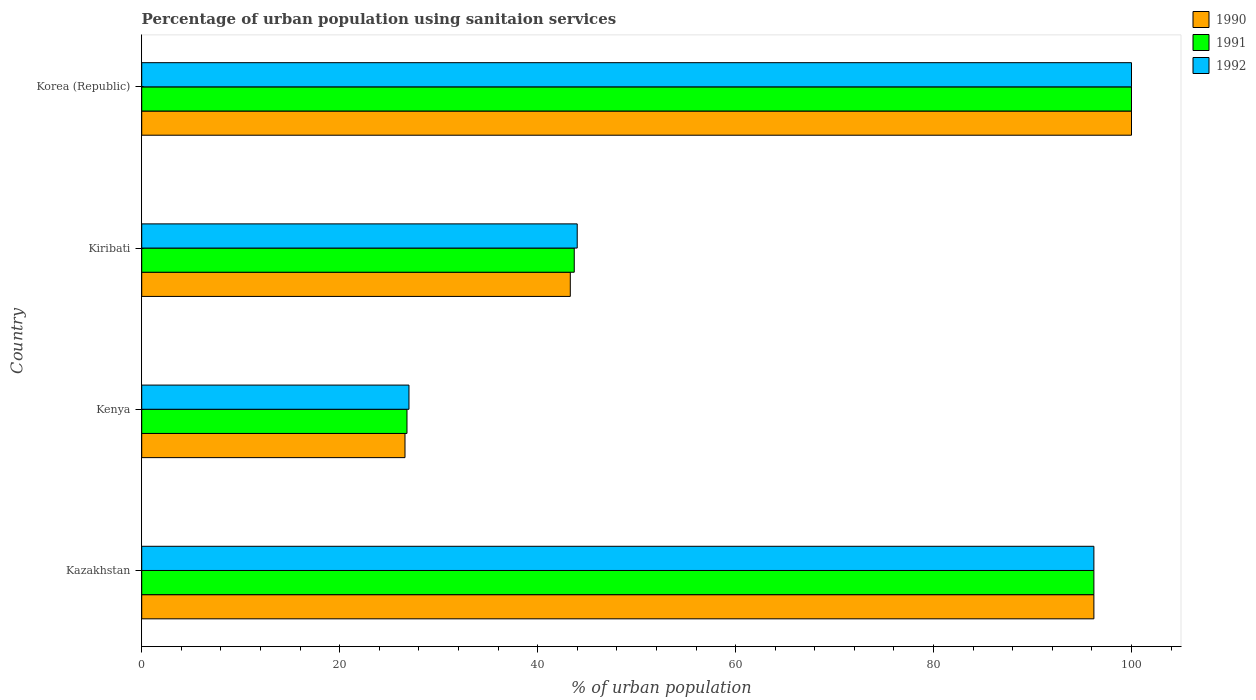Are the number of bars on each tick of the Y-axis equal?
Offer a terse response. Yes. How many bars are there on the 1st tick from the bottom?
Provide a succinct answer. 3. What is the label of the 3rd group of bars from the top?
Your response must be concise. Kenya. What is the percentage of urban population using sanitaion services in 1991 in Kiribati?
Provide a succinct answer. 43.7. Across all countries, what is the minimum percentage of urban population using sanitaion services in 1991?
Offer a very short reply. 26.8. In which country was the percentage of urban population using sanitaion services in 1990 maximum?
Provide a succinct answer. Korea (Republic). In which country was the percentage of urban population using sanitaion services in 1992 minimum?
Your response must be concise. Kenya. What is the total percentage of urban population using sanitaion services in 1992 in the graph?
Offer a very short reply. 267.2. What is the difference between the percentage of urban population using sanitaion services in 1990 in Kazakhstan and that in Kiribati?
Ensure brevity in your answer.  52.9. What is the difference between the percentage of urban population using sanitaion services in 1990 in Kiribati and the percentage of urban population using sanitaion services in 1991 in Kenya?
Provide a short and direct response. 16.5. What is the average percentage of urban population using sanitaion services in 1991 per country?
Your answer should be very brief. 66.67. What is the difference between the percentage of urban population using sanitaion services in 1990 and percentage of urban population using sanitaion services in 1991 in Korea (Republic)?
Your answer should be very brief. 0. What is the ratio of the percentage of urban population using sanitaion services in 1992 in Kenya to that in Kiribati?
Offer a terse response. 0.61. Is the percentage of urban population using sanitaion services in 1992 in Kazakhstan less than that in Korea (Republic)?
Provide a succinct answer. Yes. What is the difference between the highest and the second highest percentage of urban population using sanitaion services in 1992?
Your answer should be very brief. 3.8. What is the difference between the highest and the lowest percentage of urban population using sanitaion services in 1992?
Provide a short and direct response. 73. Is the sum of the percentage of urban population using sanitaion services in 1990 in Kazakhstan and Kenya greater than the maximum percentage of urban population using sanitaion services in 1992 across all countries?
Provide a short and direct response. Yes. What does the 2nd bar from the top in Kazakhstan represents?
Your answer should be compact. 1991. Is it the case that in every country, the sum of the percentage of urban population using sanitaion services in 1992 and percentage of urban population using sanitaion services in 1990 is greater than the percentage of urban population using sanitaion services in 1991?
Keep it short and to the point. Yes. What is the difference between two consecutive major ticks on the X-axis?
Offer a terse response. 20. Does the graph contain grids?
Keep it short and to the point. No. Where does the legend appear in the graph?
Offer a terse response. Top right. How many legend labels are there?
Your answer should be compact. 3. How are the legend labels stacked?
Make the answer very short. Vertical. What is the title of the graph?
Your answer should be very brief. Percentage of urban population using sanitaion services. Does "1989" appear as one of the legend labels in the graph?
Offer a terse response. No. What is the label or title of the X-axis?
Provide a short and direct response. % of urban population. What is the label or title of the Y-axis?
Provide a short and direct response. Country. What is the % of urban population in 1990 in Kazakhstan?
Your answer should be very brief. 96.2. What is the % of urban population in 1991 in Kazakhstan?
Your answer should be compact. 96.2. What is the % of urban population in 1992 in Kazakhstan?
Provide a succinct answer. 96.2. What is the % of urban population in 1990 in Kenya?
Your answer should be compact. 26.6. What is the % of urban population of 1991 in Kenya?
Your answer should be compact. 26.8. What is the % of urban population of 1990 in Kiribati?
Your response must be concise. 43.3. What is the % of urban population of 1991 in Kiribati?
Your response must be concise. 43.7. Across all countries, what is the maximum % of urban population in 1991?
Give a very brief answer. 100. Across all countries, what is the maximum % of urban population in 1992?
Offer a very short reply. 100. Across all countries, what is the minimum % of urban population of 1990?
Your answer should be compact. 26.6. Across all countries, what is the minimum % of urban population of 1991?
Offer a very short reply. 26.8. What is the total % of urban population in 1990 in the graph?
Keep it short and to the point. 266.1. What is the total % of urban population of 1991 in the graph?
Ensure brevity in your answer.  266.7. What is the total % of urban population in 1992 in the graph?
Your answer should be very brief. 267.2. What is the difference between the % of urban population in 1990 in Kazakhstan and that in Kenya?
Provide a short and direct response. 69.6. What is the difference between the % of urban population of 1991 in Kazakhstan and that in Kenya?
Your answer should be very brief. 69.4. What is the difference between the % of urban population in 1992 in Kazakhstan and that in Kenya?
Provide a short and direct response. 69.2. What is the difference between the % of urban population in 1990 in Kazakhstan and that in Kiribati?
Keep it short and to the point. 52.9. What is the difference between the % of urban population of 1991 in Kazakhstan and that in Kiribati?
Provide a short and direct response. 52.5. What is the difference between the % of urban population in 1992 in Kazakhstan and that in Kiribati?
Your response must be concise. 52.2. What is the difference between the % of urban population in 1990 in Kenya and that in Kiribati?
Offer a very short reply. -16.7. What is the difference between the % of urban population in 1991 in Kenya and that in Kiribati?
Keep it short and to the point. -16.9. What is the difference between the % of urban population in 1992 in Kenya and that in Kiribati?
Offer a very short reply. -17. What is the difference between the % of urban population in 1990 in Kenya and that in Korea (Republic)?
Your response must be concise. -73.4. What is the difference between the % of urban population in 1991 in Kenya and that in Korea (Republic)?
Make the answer very short. -73.2. What is the difference between the % of urban population in 1992 in Kenya and that in Korea (Republic)?
Give a very brief answer. -73. What is the difference between the % of urban population of 1990 in Kiribati and that in Korea (Republic)?
Your answer should be very brief. -56.7. What is the difference between the % of urban population in 1991 in Kiribati and that in Korea (Republic)?
Provide a short and direct response. -56.3. What is the difference between the % of urban population of 1992 in Kiribati and that in Korea (Republic)?
Give a very brief answer. -56. What is the difference between the % of urban population in 1990 in Kazakhstan and the % of urban population in 1991 in Kenya?
Provide a succinct answer. 69.4. What is the difference between the % of urban population of 1990 in Kazakhstan and the % of urban population of 1992 in Kenya?
Ensure brevity in your answer.  69.2. What is the difference between the % of urban population of 1991 in Kazakhstan and the % of urban population of 1992 in Kenya?
Keep it short and to the point. 69.2. What is the difference between the % of urban population in 1990 in Kazakhstan and the % of urban population in 1991 in Kiribati?
Give a very brief answer. 52.5. What is the difference between the % of urban population in 1990 in Kazakhstan and the % of urban population in 1992 in Kiribati?
Your response must be concise. 52.2. What is the difference between the % of urban population in 1991 in Kazakhstan and the % of urban population in 1992 in Kiribati?
Your answer should be very brief. 52.2. What is the difference between the % of urban population in 1991 in Kazakhstan and the % of urban population in 1992 in Korea (Republic)?
Provide a short and direct response. -3.8. What is the difference between the % of urban population of 1990 in Kenya and the % of urban population of 1991 in Kiribati?
Offer a terse response. -17.1. What is the difference between the % of urban population of 1990 in Kenya and the % of urban population of 1992 in Kiribati?
Ensure brevity in your answer.  -17.4. What is the difference between the % of urban population in 1991 in Kenya and the % of urban population in 1992 in Kiribati?
Offer a terse response. -17.2. What is the difference between the % of urban population in 1990 in Kenya and the % of urban population in 1991 in Korea (Republic)?
Your answer should be very brief. -73.4. What is the difference between the % of urban population in 1990 in Kenya and the % of urban population in 1992 in Korea (Republic)?
Keep it short and to the point. -73.4. What is the difference between the % of urban population in 1991 in Kenya and the % of urban population in 1992 in Korea (Republic)?
Your answer should be very brief. -73.2. What is the difference between the % of urban population in 1990 in Kiribati and the % of urban population in 1991 in Korea (Republic)?
Your answer should be compact. -56.7. What is the difference between the % of urban population of 1990 in Kiribati and the % of urban population of 1992 in Korea (Republic)?
Offer a very short reply. -56.7. What is the difference between the % of urban population in 1991 in Kiribati and the % of urban population in 1992 in Korea (Republic)?
Give a very brief answer. -56.3. What is the average % of urban population in 1990 per country?
Make the answer very short. 66.53. What is the average % of urban population in 1991 per country?
Make the answer very short. 66.67. What is the average % of urban population of 1992 per country?
Your answer should be very brief. 66.8. What is the difference between the % of urban population in 1990 and % of urban population in 1991 in Kazakhstan?
Ensure brevity in your answer.  0. What is the difference between the % of urban population of 1991 and % of urban population of 1992 in Kazakhstan?
Provide a short and direct response. 0. What is the difference between the % of urban population in 1991 and % of urban population in 1992 in Kenya?
Your answer should be very brief. -0.2. What is the ratio of the % of urban population of 1990 in Kazakhstan to that in Kenya?
Your answer should be compact. 3.62. What is the ratio of the % of urban population in 1991 in Kazakhstan to that in Kenya?
Your answer should be very brief. 3.59. What is the ratio of the % of urban population of 1992 in Kazakhstan to that in Kenya?
Provide a succinct answer. 3.56. What is the ratio of the % of urban population in 1990 in Kazakhstan to that in Kiribati?
Make the answer very short. 2.22. What is the ratio of the % of urban population of 1991 in Kazakhstan to that in Kiribati?
Your answer should be compact. 2.2. What is the ratio of the % of urban population in 1992 in Kazakhstan to that in Kiribati?
Your answer should be very brief. 2.19. What is the ratio of the % of urban population of 1990 in Kazakhstan to that in Korea (Republic)?
Provide a succinct answer. 0.96. What is the ratio of the % of urban population in 1990 in Kenya to that in Kiribati?
Keep it short and to the point. 0.61. What is the ratio of the % of urban population of 1991 in Kenya to that in Kiribati?
Provide a succinct answer. 0.61. What is the ratio of the % of urban population of 1992 in Kenya to that in Kiribati?
Provide a short and direct response. 0.61. What is the ratio of the % of urban population in 1990 in Kenya to that in Korea (Republic)?
Your response must be concise. 0.27. What is the ratio of the % of urban population in 1991 in Kenya to that in Korea (Republic)?
Offer a very short reply. 0.27. What is the ratio of the % of urban population in 1992 in Kenya to that in Korea (Republic)?
Your answer should be compact. 0.27. What is the ratio of the % of urban population of 1990 in Kiribati to that in Korea (Republic)?
Your answer should be compact. 0.43. What is the ratio of the % of urban population in 1991 in Kiribati to that in Korea (Republic)?
Your answer should be very brief. 0.44. What is the ratio of the % of urban population of 1992 in Kiribati to that in Korea (Republic)?
Keep it short and to the point. 0.44. What is the difference between the highest and the lowest % of urban population in 1990?
Offer a terse response. 73.4. What is the difference between the highest and the lowest % of urban population of 1991?
Your answer should be very brief. 73.2. 